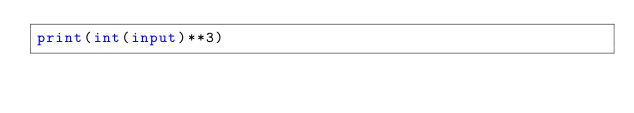Convert code to text. <code><loc_0><loc_0><loc_500><loc_500><_Python_>print(int(input)**3)</code> 